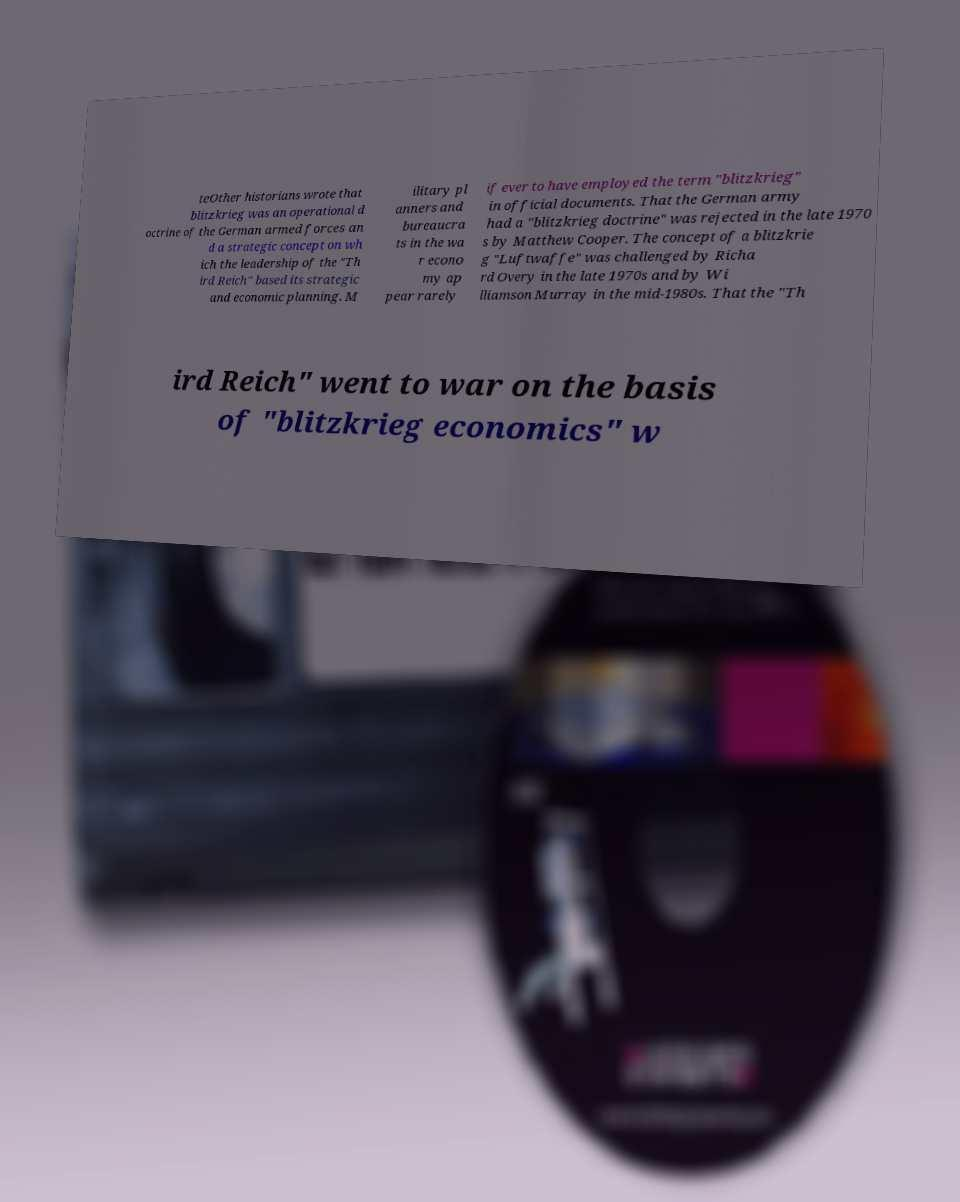I need the written content from this picture converted into text. Can you do that? teOther historians wrote that blitzkrieg was an operational d octrine of the German armed forces an d a strategic concept on wh ich the leadership of the "Th ird Reich" based its strategic and economic planning. M ilitary pl anners and bureaucra ts in the wa r econo my ap pear rarely if ever to have employed the term "blitzkrieg" in official documents. That the German army had a "blitzkrieg doctrine" was rejected in the late 1970 s by Matthew Cooper. The concept of a blitzkrie g "Luftwaffe" was challenged by Richa rd Overy in the late 1970s and by Wi lliamson Murray in the mid-1980s. That the "Th ird Reich" went to war on the basis of "blitzkrieg economics" w 